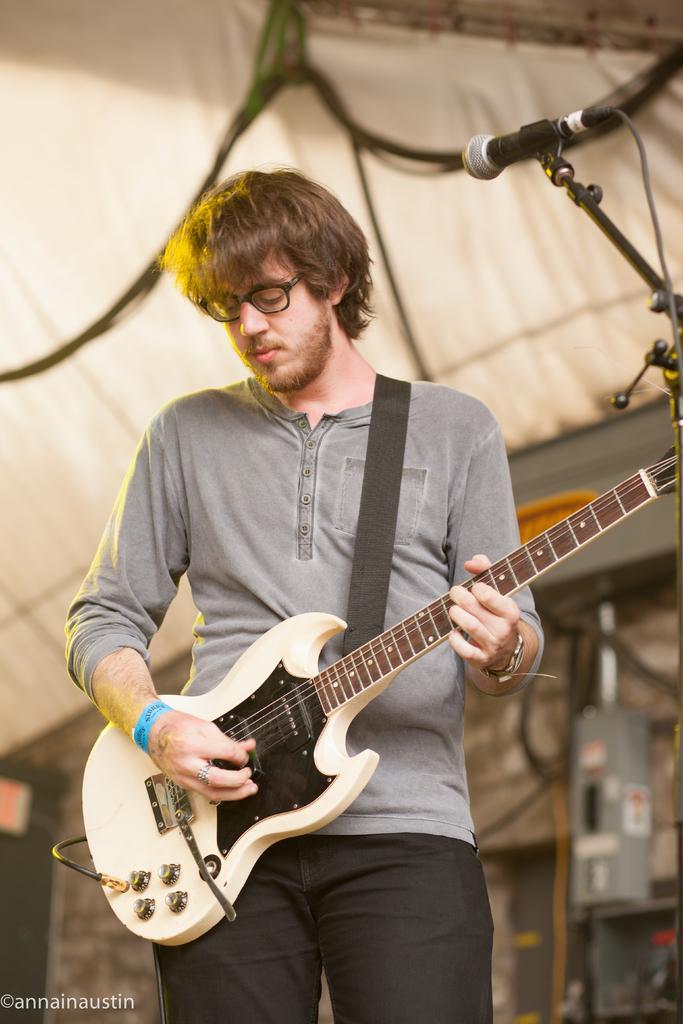Describe this image in one or two sentences. As we can see in the image there is a man holding guitar and there is a mic. 